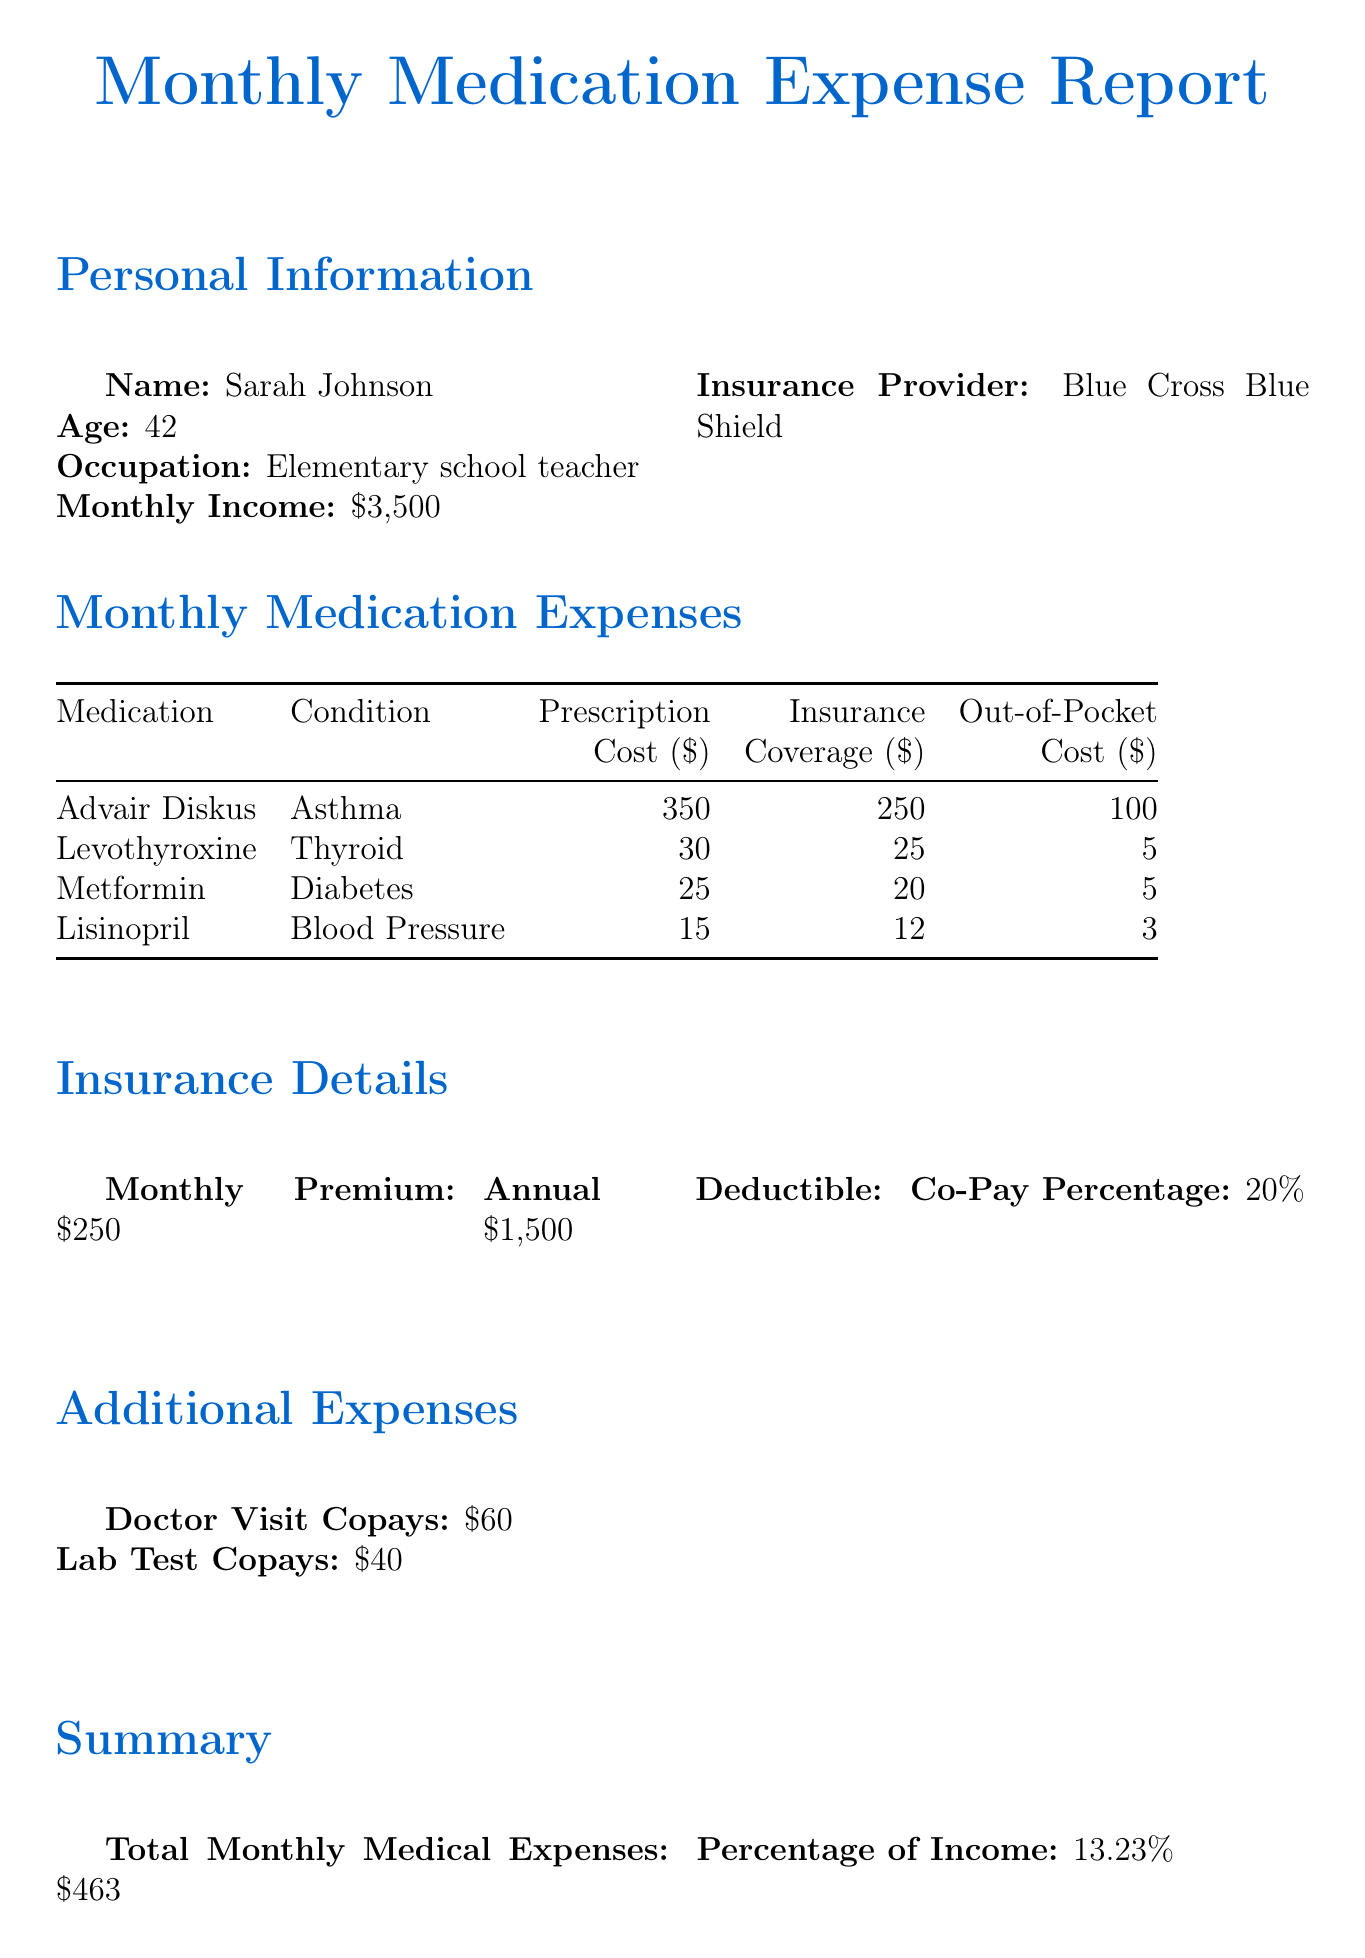What is the patient's name? The patient's name is presented at the beginning of the report under Personal Information.
Answer: Sarah Johnson What is the total monthly medical expenses? The total monthly medical expenses are calculated and summarized in the report's Summary section.
Answer: $463 What is the insurance provider for the patient? The insurance provider is specified in the Personal Information section of the document.
Answer: Blue Cross Blue Shield How much does the patient pay out-of-pocket for Levothyroxine? The out-of-pocket cost for Levothyroxine is listed in the Monthly Medication Expenses table.
Answer: $5 What percentage of the patient's income is spent on medical expenses? The percentage is mentioned in the Summary section as part of the financial breakdown.
Answer: 13.23% How much is the monthly premium for the insurance? The monthly premium is provided in the Insurance Details section of the report.
Answer: $250 What is the prescription cost of Advair Diskus? The prescription cost for Advair Diskus is detailed in the Monthly Medication Expenses table.
Answer: $350 Which legislation does the patient support? The supported legislation is clearly stated at the end of the report.
Answer: Affordable Prescription Drug Act What is the annual deductible for the insurance? The annual deductible is specified in the Insurance Details section of the document.
Answer: $1,500 